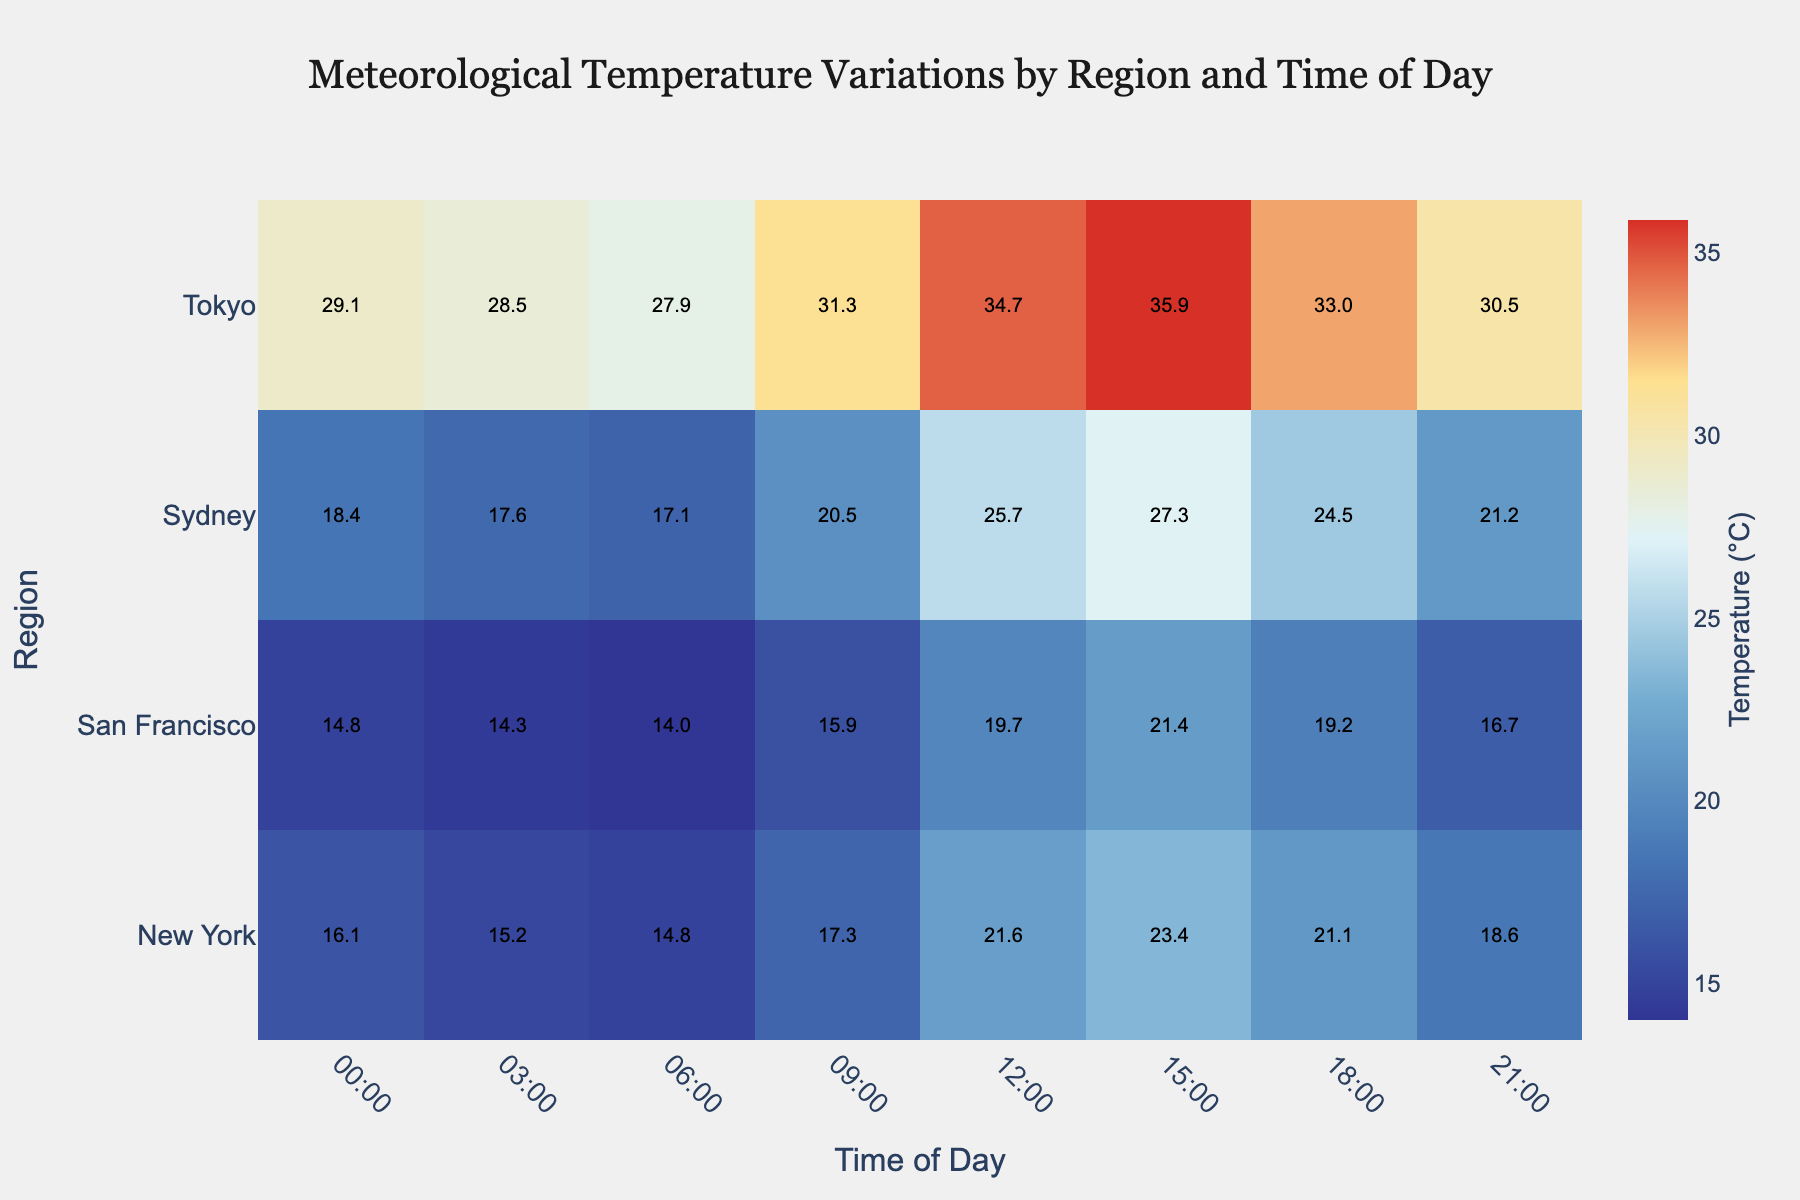what is the title of the heatmap? Look at the top of the figure; the title is prominently displayed.
Answer: Meteorological Temperature Variations by Region and Time of Day How does the temperature at 12:00 in Tokyo compare to the temperature at 12:00 in New York? Check the cell corresponding to 12:00 and Tokyo, and the cell corresponding to 12:00 and New York. Compare their values.
Answer: Tokyo is hotter What time of day shows the lowest temperature in San Francisco? Find the row corresponding to San Francisco and check for the lowest value across all columns (times of day).
Answer: 06:00 Which region shows the highest temperature overall and what is that temperature? Scan all cells to identify the highest temperature value and note the corresponding region.
Answer: Tokyo, 35.9°C What is the average temperature in Sydney across all times of the day? Sum all the temperatures in the Sydney row and divide by the number of times of day (8).
Answer: 21.68°C Which region has the smallest difference between its highest and lowest temperatures? For each region, subtract the lowest temperature from the highest temperature to find the difference, and identify the smallest one.
Answer: San Francisco Compare the midday temperatures (12:00) across all regions. Which region is the coolest? Look at the column corresponding to 12:00 and find the lowest temperature among all regions.
Answer: San Francisco What is the most visually prominent color used for the highest temperatures and what temperature range does it represent? Identify the most vivid color on the heatmap which is used to represent the highest temperature range.
Answer: Red, representing around 35.9°C How does the temperature variation in New York from morning (06:00) to afternoon (15:00) compare to Sydney over the same times? Calculate the difference in temperature from 06:00 to 15:00 for both New York and Sydney, then compare the differences. New York: 23.4 - 14.8, Sydney: 27.3 - 17.1
Answer: New York has less variation What patterns can you observe about nighttime temperatures (00:00, 03:00, 21:00) across different regions? Observe the cells corresponding to 00:00, 03:00, and 21:00 for each region to detect any general patterns or trends.
Answer: Lower than daytime in general 